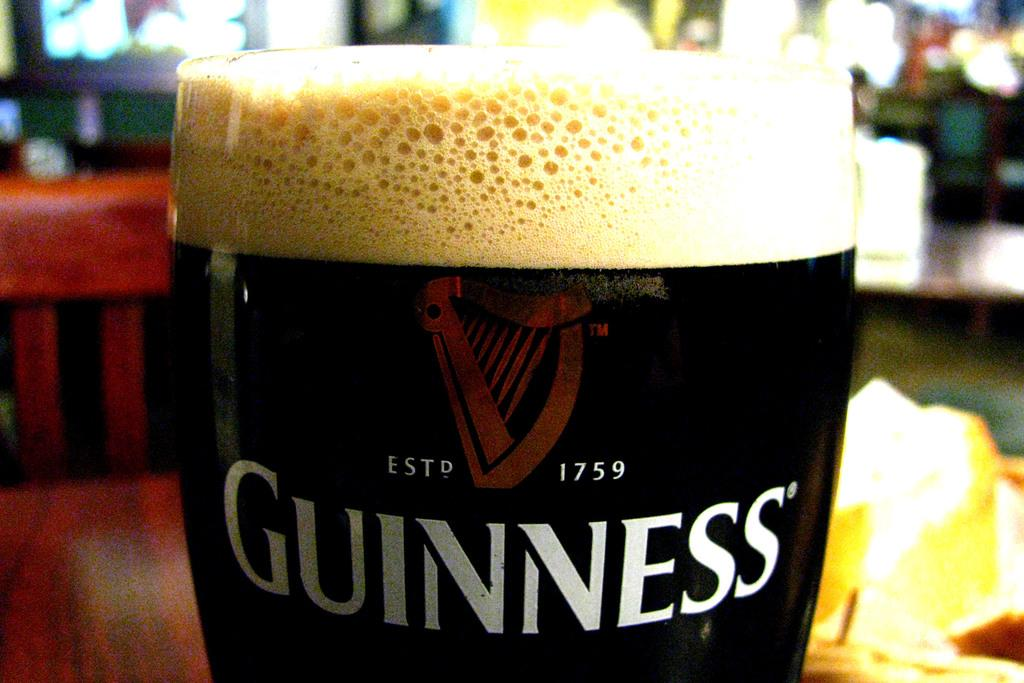<image>
Relay a brief, clear account of the picture shown. A very full Guinness glass sports a foamy head on top. 